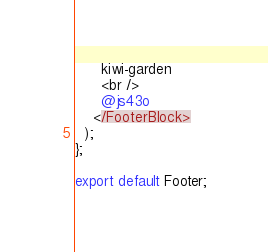Convert code to text. <code><loc_0><loc_0><loc_500><loc_500><_TypeScript_>      kiwi-garden
      <br />
      @js43o
    </FooterBlock>
  );
};

export default Footer;
</code> 